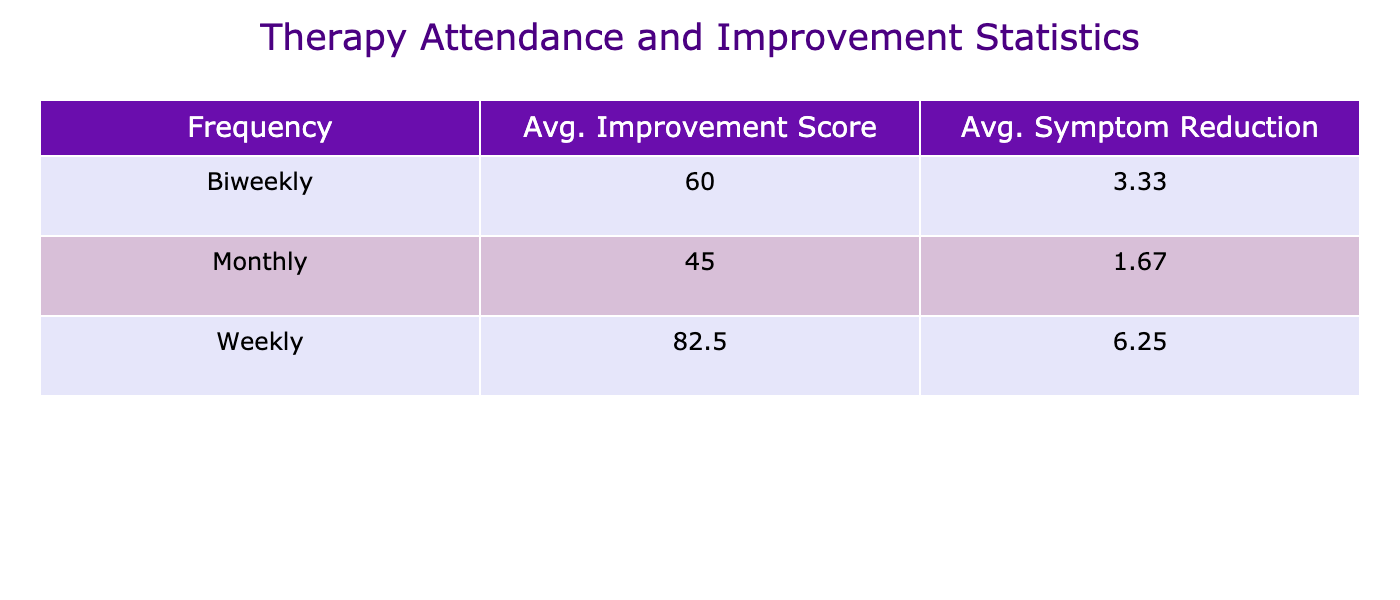What is the average improvement score for biweekly therapy attendance? From the table, we find the improvement scores for biweekly therapy attendance are 60 and 55. The average is calculated as (60 + 55) / 2 = 57.5.
Answer: 57.5 What is the average symptom reduction for weekly therapy attendees? For weekly attendees, the symptom reductions are calculated from the data: 8 - 3 = 5, 9 - 2 = 7, 8 - 1 = 7, and 8 - 2 = 6. The average reduction is (5 + 7 + 7 + 6) / 4 = 6.25.
Answer: 6.25 Is there a teenager with a therapy attendance frequency of monthly that had an improvement score higher than 45? The improvement scores for teenagers with monthly attendance are 40, 50, and 45. Since all are less than or equal to 45, the answer is false.
Answer: No What is the therapy attendance frequency with the highest average improvement score? The average improvement scores for each frequency are: Weekly (75), Biweekly (57.5), and Monthly (45). The highest score is for weekly attendance, indicating that it is the most effective.
Answer: Weekly What is the difference in average symptom reduction between weekly and monthly therapy attendees? The average reduction for weekly attendees is 6.25 and for monthly is (1 + 1 + 2) / 3 = 1.33. The difference is 6.25 - 1.33 = 4.92.
Answer: 4.92 What is the average improvement score for all therapy types combined? Adding up the improvement scores 75, 60, 40, 80, 55, 50, 90, 65, 45, and 85, we get a total of 715 and there are 10 teenagers. The average improvement score is 715 / 10 = 71.5.
Answer: 71.5 Are there more teenagers with weekly attendance or biweekly attendance? There are four entries with weekly attendance (Teenager 1, 4, 7, and 10) and three entries with biweekly attendance (Teenager 2, 5, and 8). Therefore, there are more teenagers with weekly attendance.
Answer: Yes What is the average improvement score for group therapy? Only one teenager received group therapy, which has an improvement score of 80. Therefore, the average score is also 80, since there are no other scores to average.
Answer: 80 